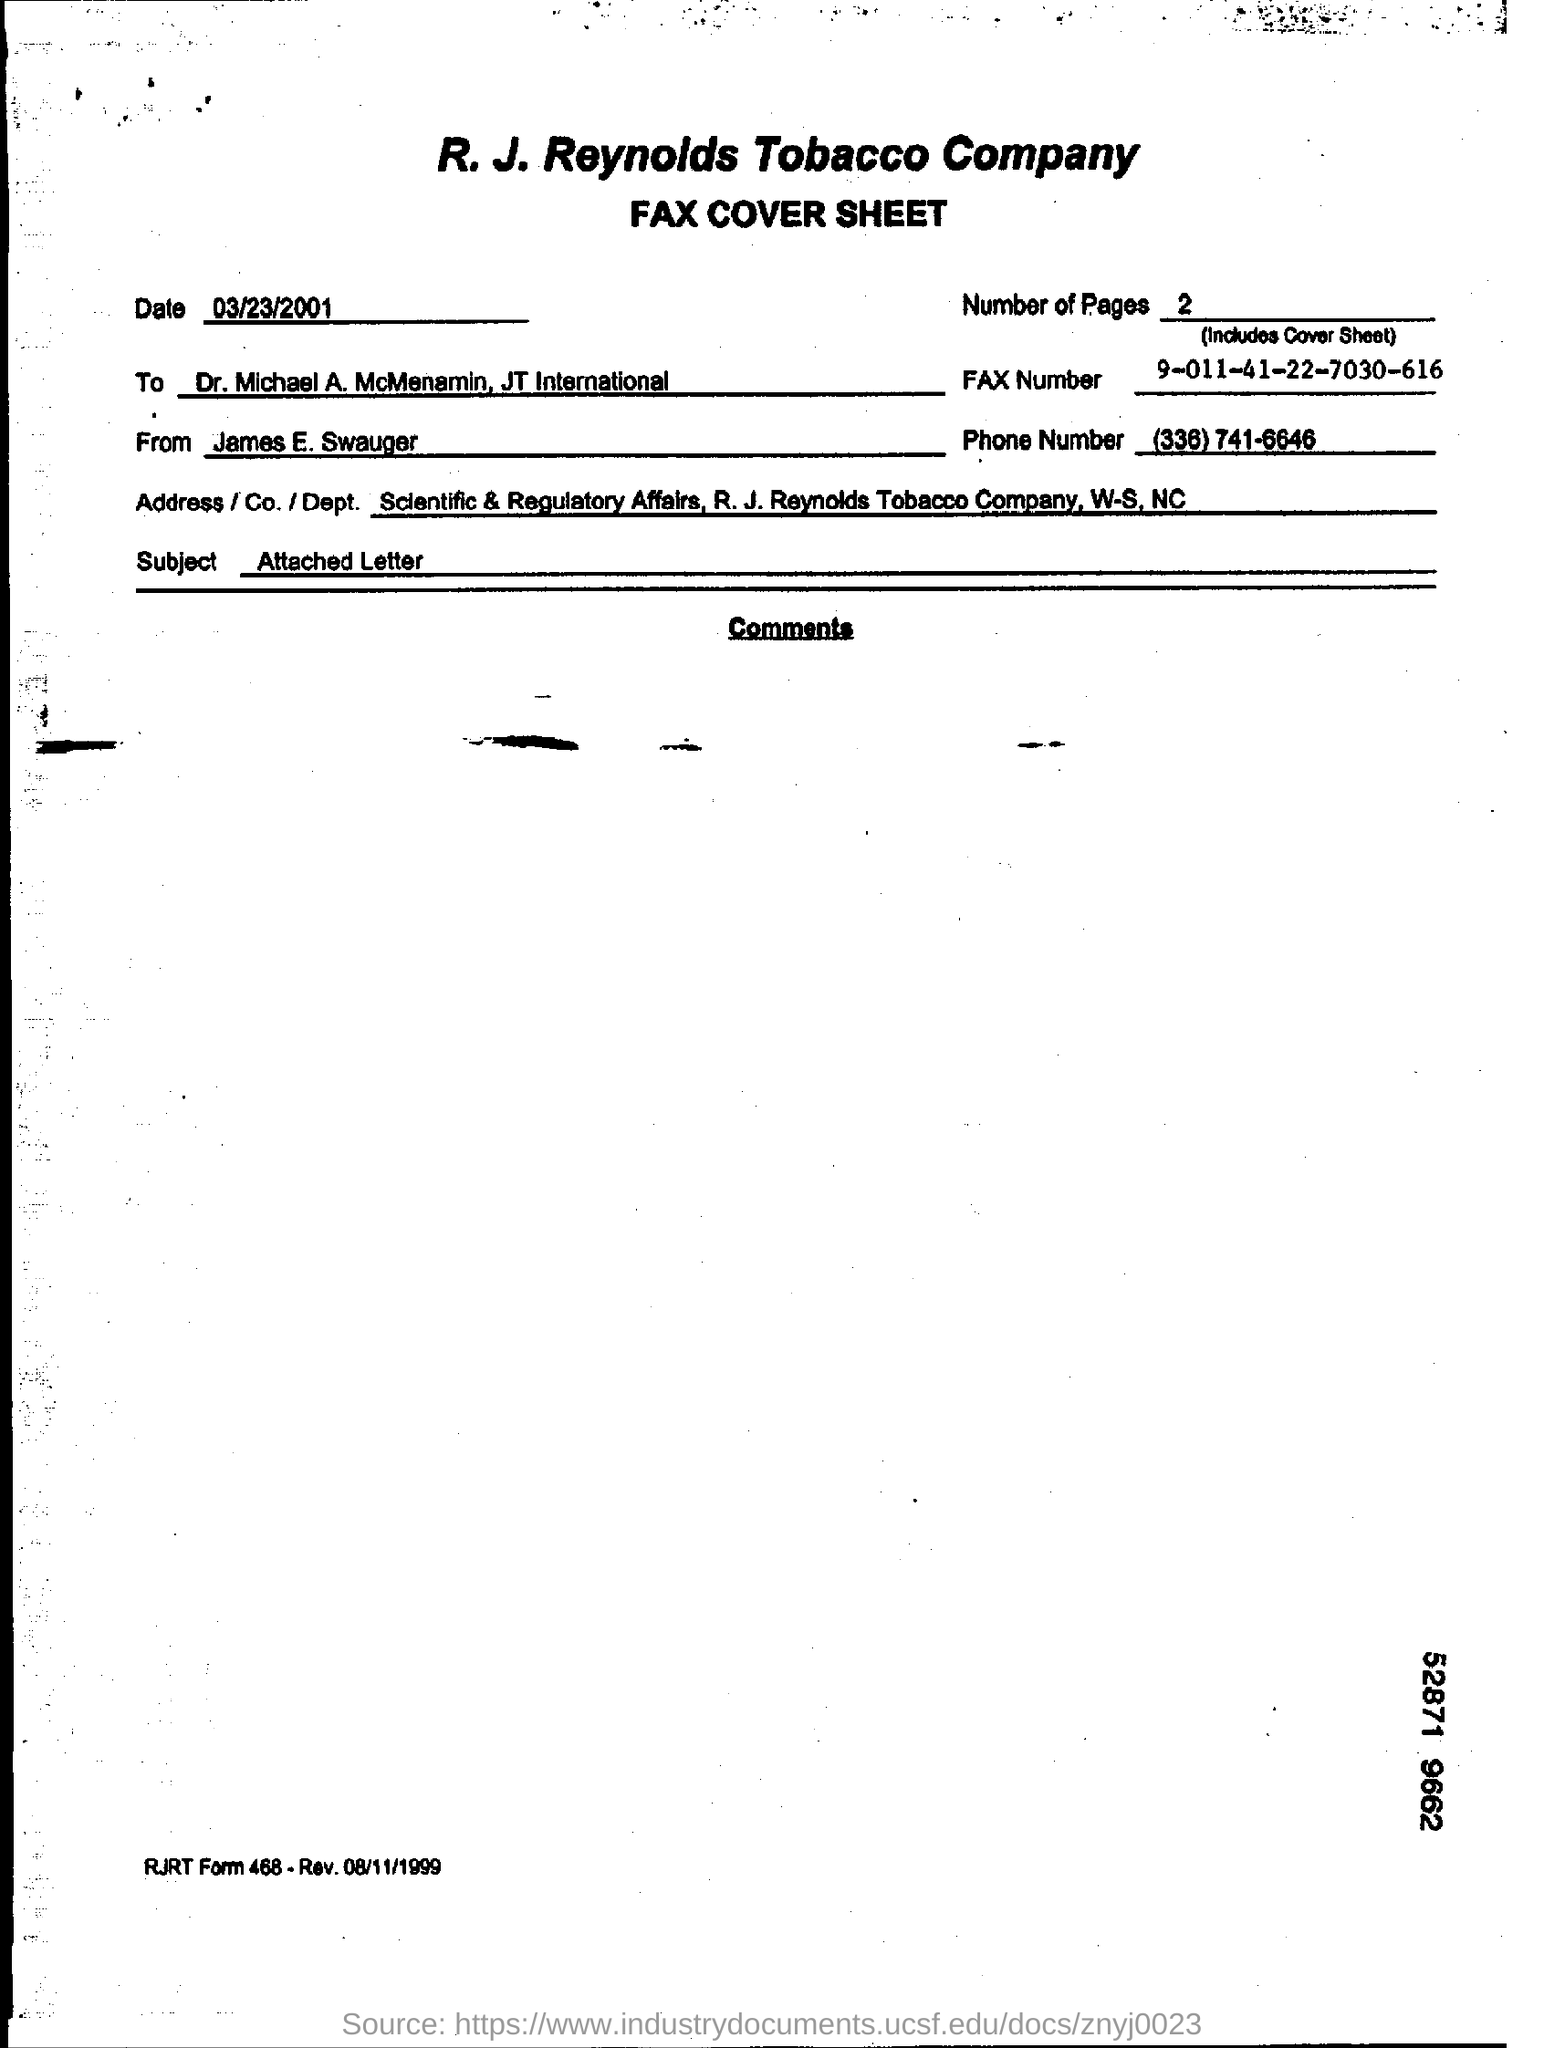What is the date mentioned in the fax cover sheet?
Your response must be concise. 03/23/2001. How many pages are there in the fax including cover sheet?
Provide a succinct answer. 2. What is the Fax number given?
Offer a terse response. 9-011-41-22-7030-616. Who is the sender of the FAX?
Your answer should be compact. James E. Swauger. To whom, the Fax is being sent?
Your answer should be very brief. Dr. Michael A. McMenamin, JT International. What is the phone number given in the fax cover sheet?
Keep it short and to the point. (336) 741-6646. What is the subject mentioned in the fax cover sheet?
Provide a succinct answer. Attached Letter. 